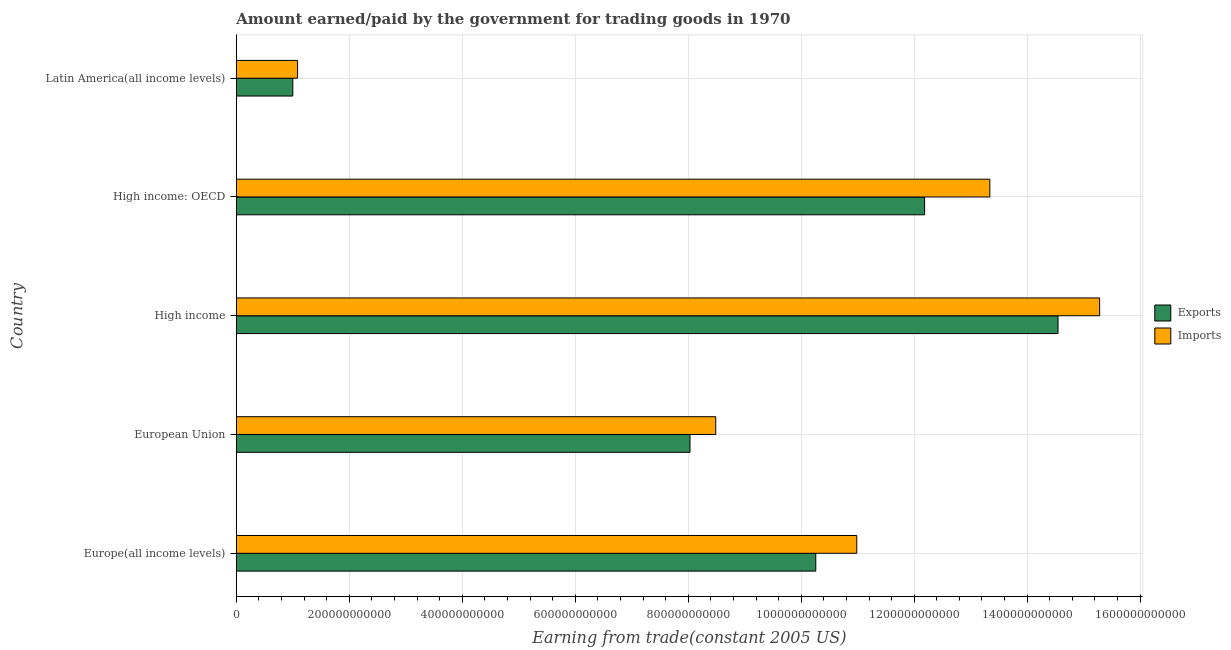Are the number of bars per tick equal to the number of legend labels?
Your answer should be very brief. Yes. Are the number of bars on each tick of the Y-axis equal?
Your response must be concise. Yes. How many bars are there on the 3rd tick from the bottom?
Provide a short and direct response. 2. In how many cases, is the number of bars for a given country not equal to the number of legend labels?
Provide a short and direct response. 0. What is the amount earned from exports in High income?
Keep it short and to the point. 1.45e+12. Across all countries, what is the maximum amount earned from exports?
Provide a short and direct response. 1.45e+12. Across all countries, what is the minimum amount earned from exports?
Your answer should be very brief. 1.00e+11. In which country was the amount paid for imports maximum?
Offer a very short reply. High income. In which country was the amount earned from exports minimum?
Provide a short and direct response. Latin America(all income levels). What is the total amount paid for imports in the graph?
Make the answer very short. 4.92e+12. What is the difference between the amount paid for imports in European Union and that in Latin America(all income levels)?
Keep it short and to the point. 7.40e+11. What is the difference between the amount paid for imports in High income and the amount earned from exports in Europe(all income levels)?
Provide a short and direct response. 5.02e+11. What is the average amount earned from exports per country?
Provide a short and direct response. 9.20e+11. What is the difference between the amount earned from exports and amount paid for imports in Latin America(all income levels)?
Your response must be concise. -8.43e+09. In how many countries, is the amount earned from exports greater than 560000000000 US$?
Keep it short and to the point. 4. What is the ratio of the amount paid for imports in High income to that in Latin America(all income levels)?
Provide a short and direct response. 14.08. Is the difference between the amount earned from exports in Europe(all income levels) and High income greater than the difference between the amount paid for imports in Europe(all income levels) and High income?
Offer a very short reply. Yes. What is the difference between the highest and the second highest amount paid for imports?
Ensure brevity in your answer.  1.94e+11. What is the difference between the highest and the lowest amount paid for imports?
Offer a very short reply. 1.42e+12. Is the sum of the amount earned from exports in Europe(all income levels) and European Union greater than the maximum amount paid for imports across all countries?
Your answer should be very brief. Yes. What does the 1st bar from the top in High income: OECD represents?
Provide a short and direct response. Imports. What does the 1st bar from the bottom in Europe(all income levels) represents?
Your answer should be very brief. Exports. Are all the bars in the graph horizontal?
Your response must be concise. Yes. How many countries are there in the graph?
Make the answer very short. 5. What is the difference between two consecutive major ticks on the X-axis?
Your answer should be compact. 2.00e+11. Does the graph contain grids?
Your answer should be compact. Yes. How many legend labels are there?
Ensure brevity in your answer.  2. How are the legend labels stacked?
Give a very brief answer. Vertical. What is the title of the graph?
Make the answer very short. Amount earned/paid by the government for trading goods in 1970. What is the label or title of the X-axis?
Your answer should be very brief. Earning from trade(constant 2005 US). What is the Earning from trade(constant 2005 US) in Exports in Europe(all income levels)?
Provide a short and direct response. 1.03e+12. What is the Earning from trade(constant 2005 US) in Imports in Europe(all income levels)?
Give a very brief answer. 1.10e+12. What is the Earning from trade(constant 2005 US) in Exports in European Union?
Keep it short and to the point. 8.03e+11. What is the Earning from trade(constant 2005 US) of Imports in European Union?
Provide a succinct answer. 8.49e+11. What is the Earning from trade(constant 2005 US) in Exports in High income?
Provide a short and direct response. 1.45e+12. What is the Earning from trade(constant 2005 US) in Imports in High income?
Offer a very short reply. 1.53e+12. What is the Earning from trade(constant 2005 US) in Exports in High income: OECD?
Give a very brief answer. 1.22e+12. What is the Earning from trade(constant 2005 US) of Imports in High income: OECD?
Offer a terse response. 1.33e+12. What is the Earning from trade(constant 2005 US) of Exports in Latin America(all income levels)?
Offer a very short reply. 1.00e+11. What is the Earning from trade(constant 2005 US) of Imports in Latin America(all income levels)?
Offer a terse response. 1.09e+11. Across all countries, what is the maximum Earning from trade(constant 2005 US) of Exports?
Your response must be concise. 1.45e+12. Across all countries, what is the maximum Earning from trade(constant 2005 US) of Imports?
Your answer should be compact. 1.53e+12. Across all countries, what is the minimum Earning from trade(constant 2005 US) of Exports?
Offer a terse response. 1.00e+11. Across all countries, what is the minimum Earning from trade(constant 2005 US) of Imports?
Provide a succinct answer. 1.09e+11. What is the total Earning from trade(constant 2005 US) in Exports in the graph?
Keep it short and to the point. 4.60e+12. What is the total Earning from trade(constant 2005 US) of Imports in the graph?
Your answer should be compact. 4.92e+12. What is the difference between the Earning from trade(constant 2005 US) in Exports in Europe(all income levels) and that in European Union?
Offer a very short reply. 2.23e+11. What is the difference between the Earning from trade(constant 2005 US) in Imports in Europe(all income levels) and that in European Union?
Your answer should be very brief. 2.50e+11. What is the difference between the Earning from trade(constant 2005 US) in Exports in Europe(all income levels) and that in High income?
Offer a terse response. -4.29e+11. What is the difference between the Earning from trade(constant 2005 US) of Imports in Europe(all income levels) and that in High income?
Keep it short and to the point. -4.30e+11. What is the difference between the Earning from trade(constant 2005 US) in Exports in Europe(all income levels) and that in High income: OECD?
Keep it short and to the point. -1.93e+11. What is the difference between the Earning from trade(constant 2005 US) of Imports in Europe(all income levels) and that in High income: OECD?
Make the answer very short. -2.35e+11. What is the difference between the Earning from trade(constant 2005 US) of Exports in Europe(all income levels) and that in Latin America(all income levels)?
Provide a succinct answer. 9.26e+11. What is the difference between the Earning from trade(constant 2005 US) in Imports in Europe(all income levels) and that in Latin America(all income levels)?
Your response must be concise. 9.90e+11. What is the difference between the Earning from trade(constant 2005 US) in Exports in European Union and that in High income?
Your answer should be very brief. -6.51e+11. What is the difference between the Earning from trade(constant 2005 US) of Imports in European Union and that in High income?
Your response must be concise. -6.80e+11. What is the difference between the Earning from trade(constant 2005 US) of Exports in European Union and that in High income: OECD?
Offer a terse response. -4.15e+11. What is the difference between the Earning from trade(constant 2005 US) in Imports in European Union and that in High income: OECD?
Provide a succinct answer. -4.85e+11. What is the difference between the Earning from trade(constant 2005 US) in Exports in European Union and that in Latin America(all income levels)?
Keep it short and to the point. 7.03e+11. What is the difference between the Earning from trade(constant 2005 US) of Imports in European Union and that in Latin America(all income levels)?
Your answer should be very brief. 7.40e+11. What is the difference between the Earning from trade(constant 2005 US) of Exports in High income and that in High income: OECD?
Provide a short and direct response. 2.36e+11. What is the difference between the Earning from trade(constant 2005 US) in Imports in High income and that in High income: OECD?
Keep it short and to the point. 1.94e+11. What is the difference between the Earning from trade(constant 2005 US) of Exports in High income and that in Latin America(all income levels)?
Keep it short and to the point. 1.35e+12. What is the difference between the Earning from trade(constant 2005 US) in Imports in High income and that in Latin America(all income levels)?
Your answer should be very brief. 1.42e+12. What is the difference between the Earning from trade(constant 2005 US) of Exports in High income: OECD and that in Latin America(all income levels)?
Provide a short and direct response. 1.12e+12. What is the difference between the Earning from trade(constant 2005 US) in Imports in High income: OECD and that in Latin America(all income levels)?
Provide a short and direct response. 1.23e+12. What is the difference between the Earning from trade(constant 2005 US) in Exports in Europe(all income levels) and the Earning from trade(constant 2005 US) in Imports in European Union?
Your response must be concise. 1.77e+11. What is the difference between the Earning from trade(constant 2005 US) of Exports in Europe(all income levels) and the Earning from trade(constant 2005 US) of Imports in High income?
Your answer should be very brief. -5.02e+11. What is the difference between the Earning from trade(constant 2005 US) in Exports in Europe(all income levels) and the Earning from trade(constant 2005 US) in Imports in High income: OECD?
Provide a succinct answer. -3.08e+11. What is the difference between the Earning from trade(constant 2005 US) in Exports in Europe(all income levels) and the Earning from trade(constant 2005 US) in Imports in Latin America(all income levels)?
Your answer should be very brief. 9.17e+11. What is the difference between the Earning from trade(constant 2005 US) of Exports in European Union and the Earning from trade(constant 2005 US) of Imports in High income?
Your answer should be very brief. -7.25e+11. What is the difference between the Earning from trade(constant 2005 US) of Exports in European Union and the Earning from trade(constant 2005 US) of Imports in High income: OECD?
Make the answer very short. -5.31e+11. What is the difference between the Earning from trade(constant 2005 US) in Exports in European Union and the Earning from trade(constant 2005 US) in Imports in Latin America(all income levels)?
Your answer should be compact. 6.95e+11. What is the difference between the Earning from trade(constant 2005 US) in Exports in High income and the Earning from trade(constant 2005 US) in Imports in High income: OECD?
Your answer should be compact. 1.21e+11. What is the difference between the Earning from trade(constant 2005 US) in Exports in High income and the Earning from trade(constant 2005 US) in Imports in Latin America(all income levels)?
Provide a short and direct response. 1.35e+12. What is the difference between the Earning from trade(constant 2005 US) of Exports in High income: OECD and the Earning from trade(constant 2005 US) of Imports in Latin America(all income levels)?
Ensure brevity in your answer.  1.11e+12. What is the average Earning from trade(constant 2005 US) of Exports per country?
Your answer should be compact. 9.20e+11. What is the average Earning from trade(constant 2005 US) in Imports per country?
Ensure brevity in your answer.  9.84e+11. What is the difference between the Earning from trade(constant 2005 US) of Exports and Earning from trade(constant 2005 US) of Imports in Europe(all income levels)?
Make the answer very short. -7.26e+1. What is the difference between the Earning from trade(constant 2005 US) of Exports and Earning from trade(constant 2005 US) of Imports in European Union?
Your response must be concise. -4.55e+1. What is the difference between the Earning from trade(constant 2005 US) in Exports and Earning from trade(constant 2005 US) in Imports in High income?
Your response must be concise. -7.36e+1. What is the difference between the Earning from trade(constant 2005 US) of Exports and Earning from trade(constant 2005 US) of Imports in High income: OECD?
Offer a terse response. -1.15e+11. What is the difference between the Earning from trade(constant 2005 US) in Exports and Earning from trade(constant 2005 US) in Imports in Latin America(all income levels)?
Keep it short and to the point. -8.43e+09. What is the ratio of the Earning from trade(constant 2005 US) in Exports in Europe(all income levels) to that in European Union?
Your response must be concise. 1.28. What is the ratio of the Earning from trade(constant 2005 US) in Imports in Europe(all income levels) to that in European Union?
Ensure brevity in your answer.  1.29. What is the ratio of the Earning from trade(constant 2005 US) of Exports in Europe(all income levels) to that in High income?
Provide a succinct answer. 0.71. What is the ratio of the Earning from trade(constant 2005 US) in Imports in Europe(all income levels) to that in High income?
Make the answer very short. 0.72. What is the ratio of the Earning from trade(constant 2005 US) in Exports in Europe(all income levels) to that in High income: OECD?
Give a very brief answer. 0.84. What is the ratio of the Earning from trade(constant 2005 US) in Imports in Europe(all income levels) to that in High income: OECD?
Keep it short and to the point. 0.82. What is the ratio of the Earning from trade(constant 2005 US) of Exports in Europe(all income levels) to that in Latin America(all income levels)?
Provide a short and direct response. 10.25. What is the ratio of the Earning from trade(constant 2005 US) of Imports in Europe(all income levels) to that in Latin America(all income levels)?
Provide a succinct answer. 10.12. What is the ratio of the Earning from trade(constant 2005 US) of Exports in European Union to that in High income?
Make the answer very short. 0.55. What is the ratio of the Earning from trade(constant 2005 US) of Imports in European Union to that in High income?
Your answer should be compact. 0.56. What is the ratio of the Earning from trade(constant 2005 US) of Exports in European Union to that in High income: OECD?
Provide a short and direct response. 0.66. What is the ratio of the Earning from trade(constant 2005 US) in Imports in European Union to that in High income: OECD?
Offer a terse response. 0.64. What is the ratio of the Earning from trade(constant 2005 US) of Exports in European Union to that in Latin America(all income levels)?
Make the answer very short. 8.02. What is the ratio of the Earning from trade(constant 2005 US) in Imports in European Union to that in Latin America(all income levels)?
Keep it short and to the point. 7.82. What is the ratio of the Earning from trade(constant 2005 US) in Exports in High income to that in High income: OECD?
Ensure brevity in your answer.  1.19. What is the ratio of the Earning from trade(constant 2005 US) of Imports in High income to that in High income: OECD?
Offer a terse response. 1.15. What is the ratio of the Earning from trade(constant 2005 US) of Exports in High income to that in Latin America(all income levels)?
Give a very brief answer. 14.53. What is the ratio of the Earning from trade(constant 2005 US) of Imports in High income to that in Latin America(all income levels)?
Your answer should be compact. 14.08. What is the ratio of the Earning from trade(constant 2005 US) in Exports in High income: OECD to that in Latin America(all income levels)?
Make the answer very short. 12.17. What is the ratio of the Earning from trade(constant 2005 US) of Imports in High income: OECD to that in Latin America(all income levels)?
Offer a very short reply. 12.29. What is the difference between the highest and the second highest Earning from trade(constant 2005 US) of Exports?
Make the answer very short. 2.36e+11. What is the difference between the highest and the second highest Earning from trade(constant 2005 US) of Imports?
Provide a short and direct response. 1.94e+11. What is the difference between the highest and the lowest Earning from trade(constant 2005 US) of Exports?
Your answer should be very brief. 1.35e+12. What is the difference between the highest and the lowest Earning from trade(constant 2005 US) of Imports?
Your answer should be compact. 1.42e+12. 